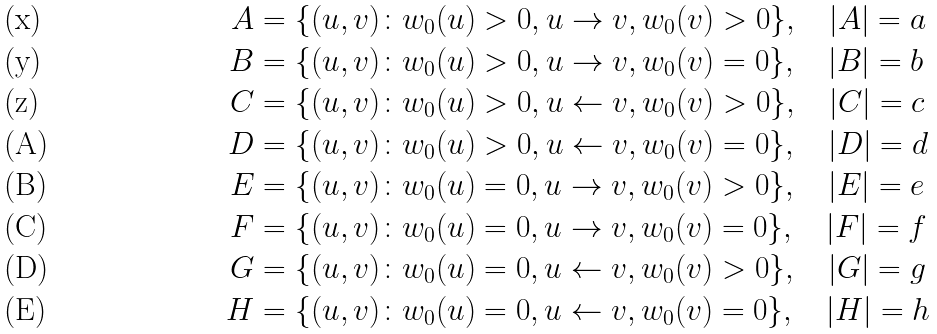<formula> <loc_0><loc_0><loc_500><loc_500>A & = \{ ( u , v ) \colon w _ { 0 } ( u ) > 0 , u \rightarrow v , w _ { 0 } ( v ) > 0 \} , \quad | A | = a \\ B & = \{ ( u , v ) \colon w _ { 0 } ( u ) > 0 , u \rightarrow v , w _ { 0 } ( v ) = 0 \} , \quad | B | = b \\ C & = \{ ( u , v ) \colon w _ { 0 } ( u ) > 0 , u \leftarrow v , w _ { 0 } ( v ) > 0 \} , \quad | C | = c \\ D & = \{ ( u , v ) \colon w _ { 0 } ( u ) > 0 , u \leftarrow v , w _ { 0 } ( v ) = 0 \} , \quad | D | = d \\ E & = \{ ( u , v ) \colon w _ { 0 } ( u ) = 0 , u \rightarrow v , w _ { 0 } ( v ) > 0 \} , \quad | E | = e \\ F & = \{ ( u , v ) \colon w _ { 0 } ( u ) = 0 , u \rightarrow v , w _ { 0 } ( v ) = 0 \} , \quad | F | = f \\ G & = \{ ( u , v ) \colon w _ { 0 } ( u ) = 0 , u \leftarrow v , w _ { 0 } ( v ) > 0 \} , \quad | G | = g \\ H & = \{ ( u , v ) \colon w _ { 0 } ( u ) = 0 , u \leftarrow v , w _ { 0 } ( v ) = 0 \} , \quad | H | = h</formula> 